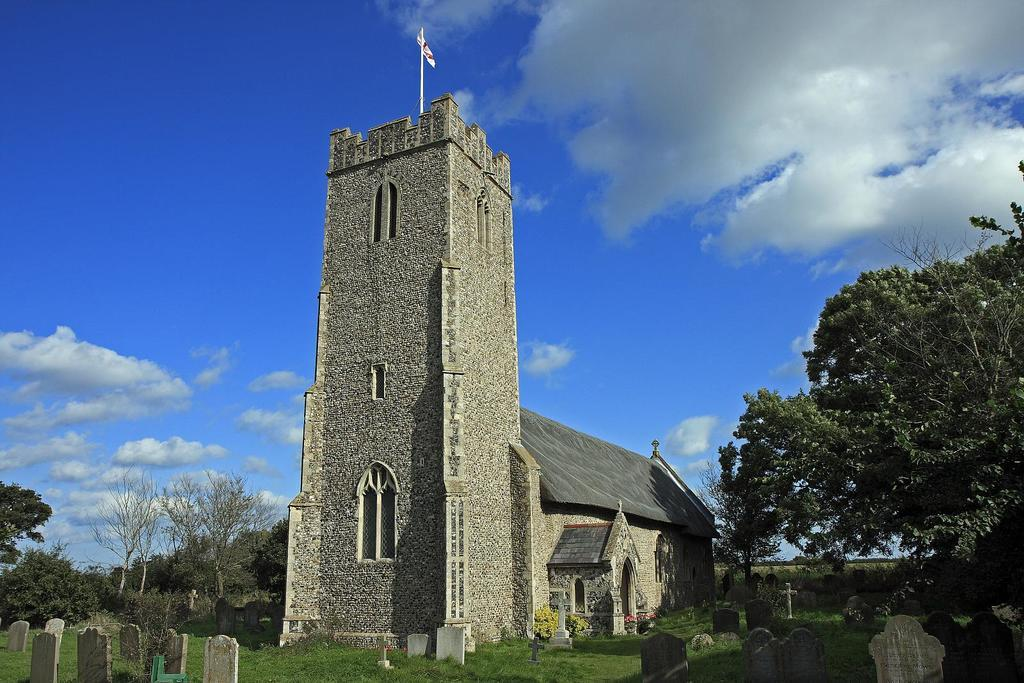What type of structure can be seen in the image? There is a building in the image. What is attached to the building tower? There is a flag on the building tower. What type of objects are present in the image that are related to burial sites? Grave stones are present in the image. What type of vegetation can be seen in the image? There is grass and trees visible in the image. What is visible in the background of the image? The sky is visible in the background of the image. What type of ink is being used to write on the rabbits in the image? There are no rabbits present in the image, and therefore no ink or writing on them. 